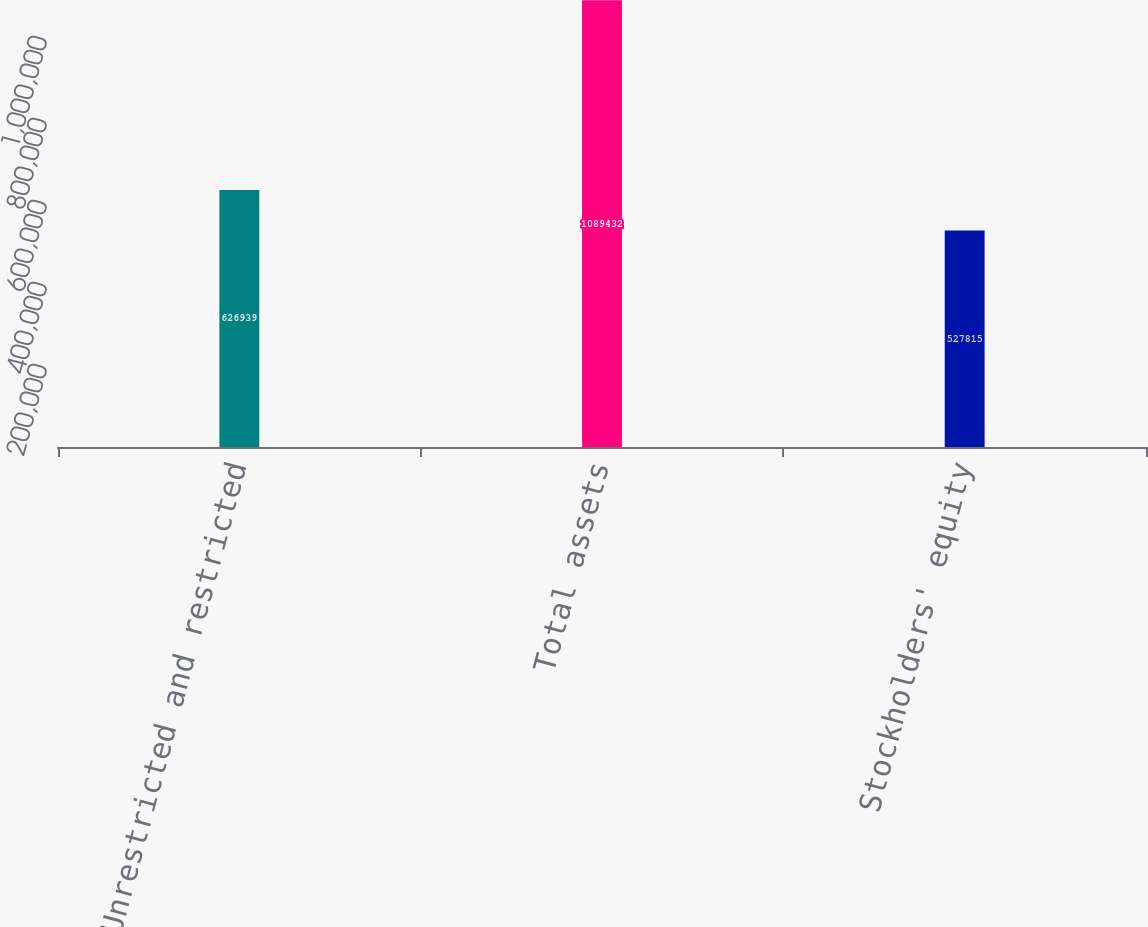Convert chart to OTSL. <chart><loc_0><loc_0><loc_500><loc_500><bar_chart><fcel>Unrestricted and restricted<fcel>Total assets<fcel>Stockholders' equity<nl><fcel>626939<fcel>1.08943e+06<fcel>527815<nl></chart> 